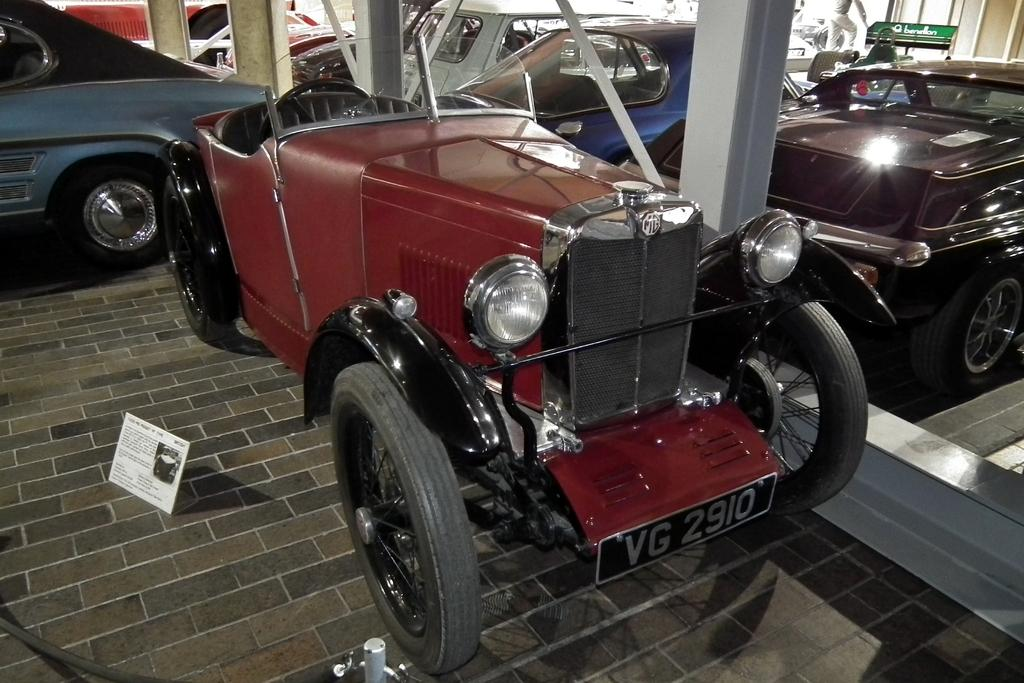<image>
Create a compact narrative representing the image presented. A vintage car has license plate numbers VG 2910. 